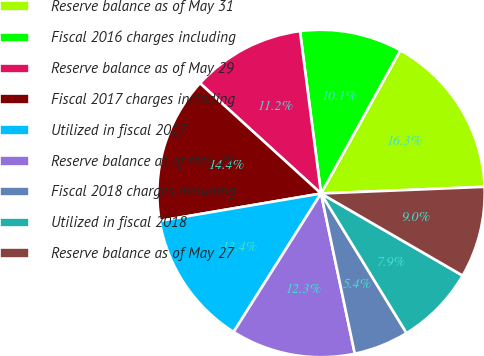<chart> <loc_0><loc_0><loc_500><loc_500><pie_chart><fcel>Reserve balance as of May 31<fcel>Fiscal 2016 charges including<fcel>Reserve balance as of May 29<fcel>Fiscal 2017 charges including<fcel>Utilized in fiscal 2017<fcel>Reserve balance as of May 28<fcel>Fiscal 2018 charges including<fcel>Utilized in fiscal 2018<fcel>Reserve balance as of May 27<nl><fcel>16.3%<fcel>10.1%<fcel>11.19%<fcel>14.44%<fcel>13.36%<fcel>12.27%<fcel>5.44%<fcel>7.89%<fcel>9.01%<nl></chart> 